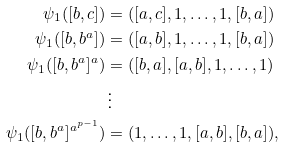Convert formula to latex. <formula><loc_0><loc_0><loc_500><loc_500>\psi _ { 1 } ( [ b , c ] ) & = ( [ a , c ] , 1 , \dots , 1 , [ b , a ] ) \\ \psi _ { 1 } ( [ b , b ^ { a } ] ) & = ( [ a , b ] , 1 , \dots , 1 , [ b , a ] ) \\ \psi _ { 1 } ( [ b , b ^ { a } ] ^ { a } ) & = ( [ b , a ] , [ a , b ] , 1 , \dots , 1 ) \\ & \, \vdots \\ \psi _ { 1 } ( [ b , b ^ { a } ] ^ { a ^ { p - 1 } } ) & = ( 1 , \dots , 1 , [ a , b ] , [ b , a ] ) ,</formula> 